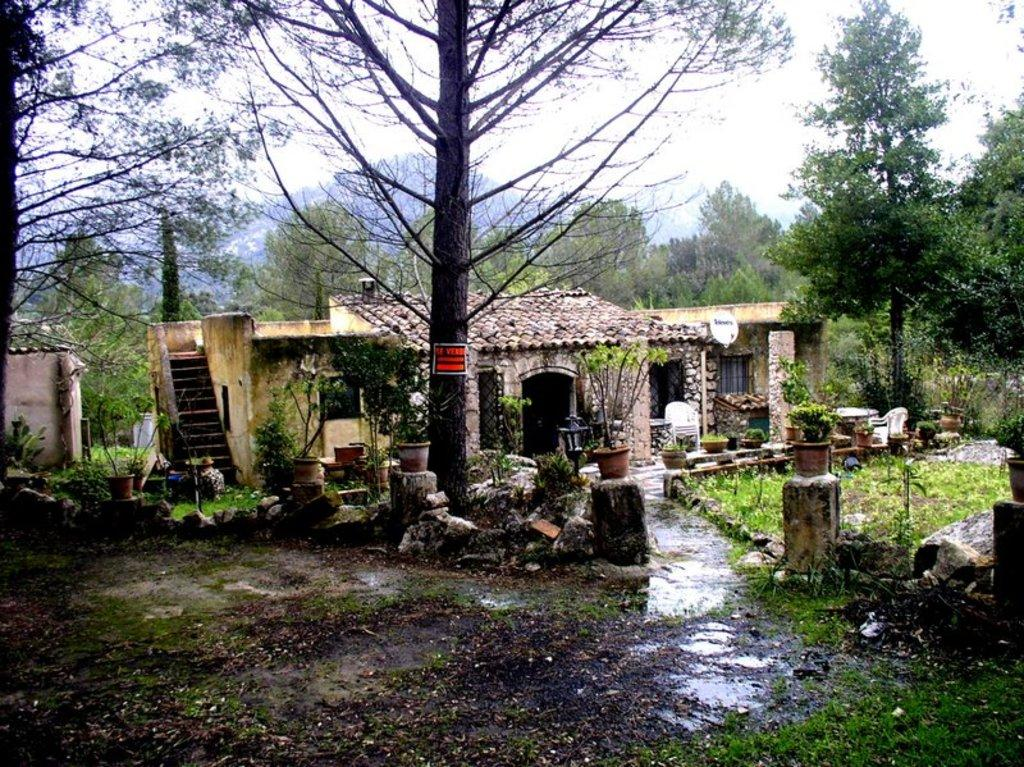What type of vegetation can be seen in the image? There are trees and plants in the image. What type of structures are present in the image? There are buildings in the image. What is visible in the background of the image? The sky is visible in the background of the image. How many ladybugs can be seen crawling on the plants in the image? There are no ladybugs present in the image; it only features trees, plants, buildings, and the sky. What type of container is being used to water the plants in the image? There is no container or pail visible in the image for watering the plants. 